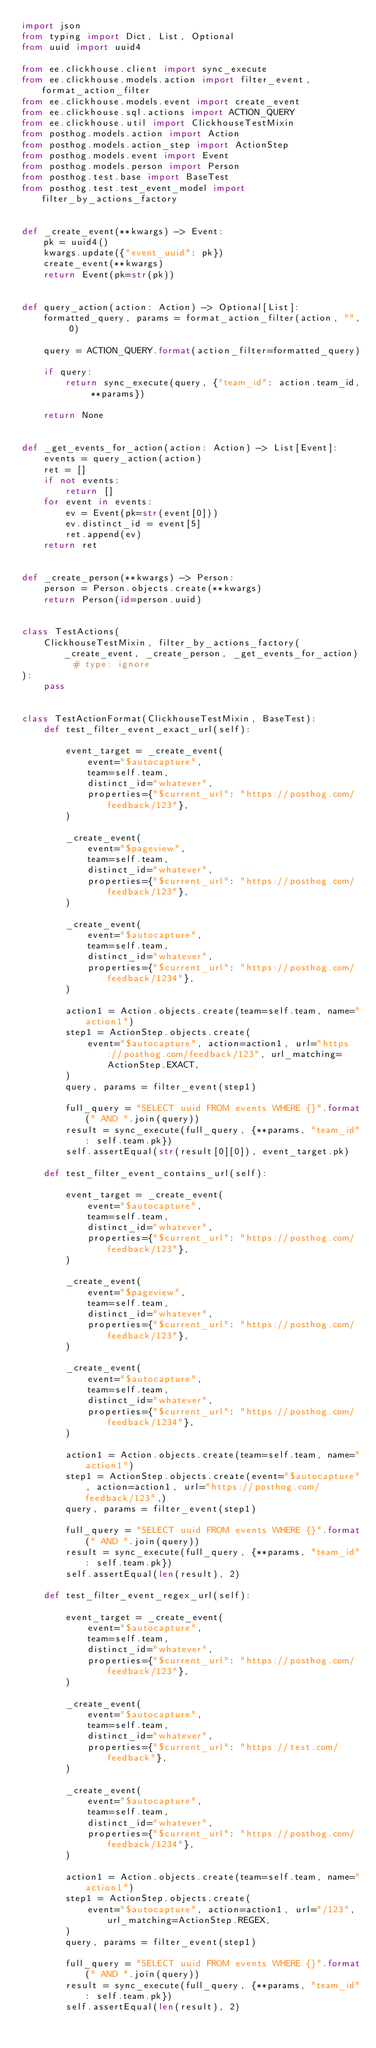<code> <loc_0><loc_0><loc_500><loc_500><_Python_>import json
from typing import Dict, List, Optional
from uuid import uuid4

from ee.clickhouse.client import sync_execute
from ee.clickhouse.models.action import filter_event, format_action_filter
from ee.clickhouse.models.event import create_event
from ee.clickhouse.sql.actions import ACTION_QUERY
from ee.clickhouse.util import ClickhouseTestMixin
from posthog.models.action import Action
from posthog.models.action_step import ActionStep
from posthog.models.event import Event
from posthog.models.person import Person
from posthog.test.base import BaseTest
from posthog.test.test_event_model import filter_by_actions_factory


def _create_event(**kwargs) -> Event:
    pk = uuid4()
    kwargs.update({"event_uuid": pk})
    create_event(**kwargs)
    return Event(pk=str(pk))


def query_action(action: Action) -> Optional[List]:
    formatted_query, params = format_action_filter(action, "", 0)

    query = ACTION_QUERY.format(action_filter=formatted_query)

    if query:
        return sync_execute(query, {"team_id": action.team_id, **params})

    return None


def _get_events_for_action(action: Action) -> List[Event]:
    events = query_action(action)
    ret = []
    if not events:
        return []
    for event in events:
        ev = Event(pk=str(event[0]))
        ev.distinct_id = event[5]
        ret.append(ev)
    return ret


def _create_person(**kwargs) -> Person:
    person = Person.objects.create(**kwargs)
    return Person(id=person.uuid)


class TestActions(
    ClickhouseTestMixin, filter_by_actions_factory(_create_event, _create_person, _get_events_for_action)  # type: ignore
):
    pass


class TestActionFormat(ClickhouseTestMixin, BaseTest):
    def test_filter_event_exact_url(self):

        event_target = _create_event(
            event="$autocapture",
            team=self.team,
            distinct_id="whatever",
            properties={"$current_url": "https://posthog.com/feedback/123"},
        )

        _create_event(
            event="$pageview",
            team=self.team,
            distinct_id="whatever",
            properties={"$current_url": "https://posthog.com/feedback/123"},
        )

        _create_event(
            event="$autocapture",
            team=self.team,
            distinct_id="whatever",
            properties={"$current_url": "https://posthog.com/feedback/1234"},
        )

        action1 = Action.objects.create(team=self.team, name="action1")
        step1 = ActionStep.objects.create(
            event="$autocapture", action=action1, url="https://posthog.com/feedback/123", url_matching=ActionStep.EXACT,
        )
        query, params = filter_event(step1)

        full_query = "SELECT uuid FROM events WHERE {}".format(" AND ".join(query))
        result = sync_execute(full_query, {**params, "team_id": self.team.pk})
        self.assertEqual(str(result[0][0]), event_target.pk)

    def test_filter_event_contains_url(self):

        event_target = _create_event(
            event="$autocapture",
            team=self.team,
            distinct_id="whatever",
            properties={"$current_url": "https://posthog.com/feedback/123"},
        )

        _create_event(
            event="$pageview",
            team=self.team,
            distinct_id="whatever",
            properties={"$current_url": "https://posthog.com/feedback/123"},
        )

        _create_event(
            event="$autocapture",
            team=self.team,
            distinct_id="whatever",
            properties={"$current_url": "https://posthog.com/feedback/1234"},
        )

        action1 = Action.objects.create(team=self.team, name="action1")
        step1 = ActionStep.objects.create(event="$autocapture", action=action1, url="https://posthog.com/feedback/123",)
        query, params = filter_event(step1)

        full_query = "SELECT uuid FROM events WHERE {}".format(" AND ".join(query))
        result = sync_execute(full_query, {**params, "team_id": self.team.pk})
        self.assertEqual(len(result), 2)

    def test_filter_event_regex_url(self):

        event_target = _create_event(
            event="$autocapture",
            team=self.team,
            distinct_id="whatever",
            properties={"$current_url": "https://posthog.com/feedback/123"},
        )

        _create_event(
            event="$autocapture",
            team=self.team,
            distinct_id="whatever",
            properties={"$current_url": "https://test.com/feedback"},
        )

        _create_event(
            event="$autocapture",
            team=self.team,
            distinct_id="whatever",
            properties={"$current_url": "https://posthog.com/feedback/1234"},
        )

        action1 = Action.objects.create(team=self.team, name="action1")
        step1 = ActionStep.objects.create(
            event="$autocapture", action=action1, url="/123", url_matching=ActionStep.REGEX,
        )
        query, params = filter_event(step1)

        full_query = "SELECT uuid FROM events WHERE {}".format(" AND ".join(query))
        result = sync_execute(full_query, {**params, "team_id": self.team.pk})
        self.assertEqual(len(result), 2)
</code> 